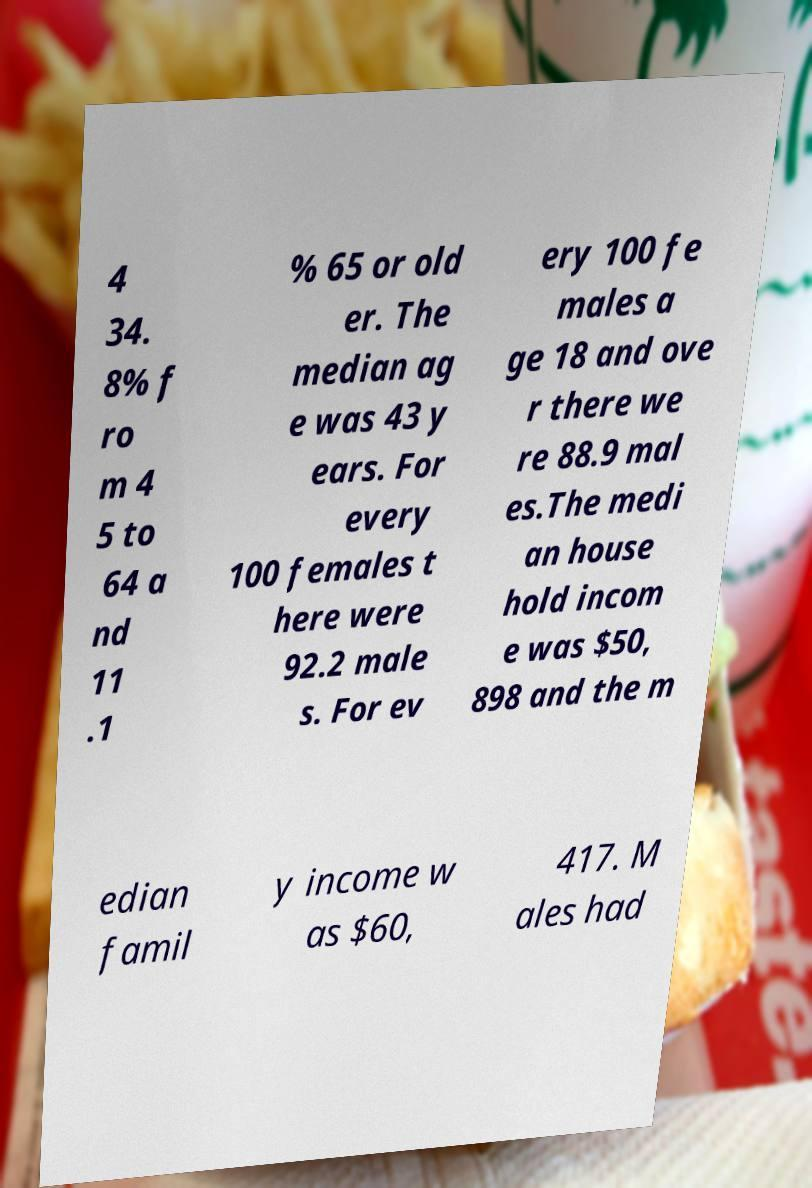Could you assist in decoding the text presented in this image and type it out clearly? 4 34. 8% f ro m 4 5 to 64 a nd 11 .1 % 65 or old er. The median ag e was 43 y ears. For every 100 females t here were 92.2 male s. For ev ery 100 fe males a ge 18 and ove r there we re 88.9 mal es.The medi an house hold incom e was $50, 898 and the m edian famil y income w as $60, 417. M ales had 